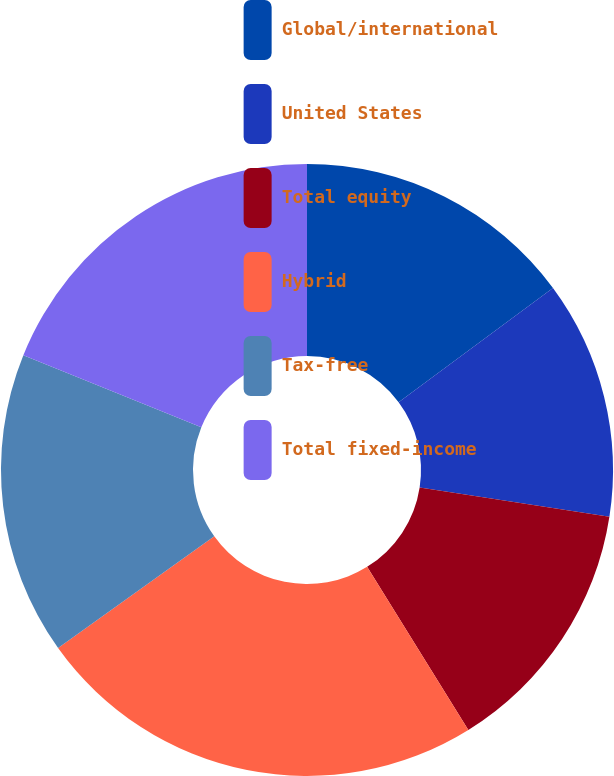Convert chart to OTSL. <chart><loc_0><loc_0><loc_500><loc_500><pie_chart><fcel>Global/international<fcel>United States<fcel>Total equity<fcel>Hybrid<fcel>Tax-free<fcel>Total fixed-income<nl><fcel>14.86%<fcel>12.58%<fcel>13.72%<fcel>23.96%<fcel>16.0%<fcel>18.88%<nl></chart> 